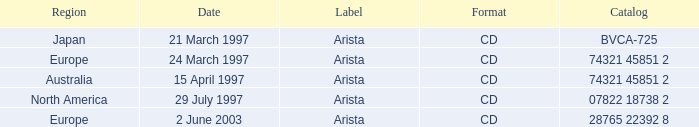What's the Date for the Region of Europe and has the Catalog of 28765 22392 8? 2 June 2003. 